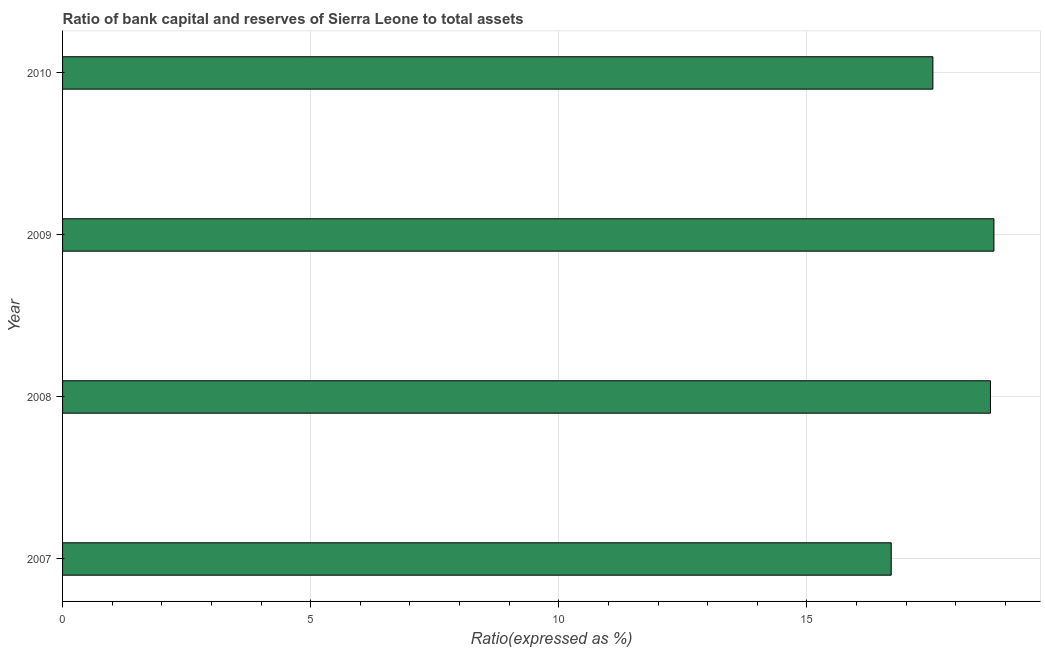Does the graph contain any zero values?
Give a very brief answer. No. Does the graph contain grids?
Make the answer very short. Yes. What is the title of the graph?
Provide a short and direct response. Ratio of bank capital and reserves of Sierra Leone to total assets. What is the label or title of the X-axis?
Your answer should be very brief. Ratio(expressed as %). What is the label or title of the Y-axis?
Offer a very short reply. Year. What is the bank capital to assets ratio in 2010?
Provide a short and direct response. 17.54. Across all years, what is the maximum bank capital to assets ratio?
Provide a succinct answer. 18.77. Across all years, what is the minimum bank capital to assets ratio?
Provide a short and direct response. 16.7. In which year was the bank capital to assets ratio maximum?
Provide a short and direct response. 2009. What is the sum of the bank capital to assets ratio?
Your response must be concise. 71.71. What is the difference between the bank capital to assets ratio in 2009 and 2010?
Keep it short and to the point. 1.23. What is the average bank capital to assets ratio per year?
Keep it short and to the point. 17.93. What is the median bank capital to assets ratio?
Make the answer very short. 18.12. In how many years, is the bank capital to assets ratio greater than 6 %?
Offer a very short reply. 4. Do a majority of the years between 2010 and 2007 (inclusive) have bank capital to assets ratio greater than 3 %?
Provide a short and direct response. Yes. What is the ratio of the bank capital to assets ratio in 2007 to that in 2010?
Your response must be concise. 0.95. What is the difference between the highest and the second highest bank capital to assets ratio?
Your response must be concise. 0.07. Is the sum of the bank capital to assets ratio in 2009 and 2010 greater than the maximum bank capital to assets ratio across all years?
Ensure brevity in your answer.  Yes. What is the difference between the highest and the lowest bank capital to assets ratio?
Ensure brevity in your answer.  2.07. In how many years, is the bank capital to assets ratio greater than the average bank capital to assets ratio taken over all years?
Give a very brief answer. 2. How many bars are there?
Provide a short and direct response. 4. Are all the bars in the graph horizontal?
Make the answer very short. Yes. What is the difference between two consecutive major ticks on the X-axis?
Your answer should be very brief. 5. What is the Ratio(expressed as %) of 2009?
Provide a succinct answer. 18.77. What is the Ratio(expressed as %) in 2010?
Provide a succinct answer. 17.54. What is the difference between the Ratio(expressed as %) in 2007 and 2009?
Your answer should be compact. -2.07. What is the difference between the Ratio(expressed as %) in 2007 and 2010?
Offer a terse response. -0.84. What is the difference between the Ratio(expressed as %) in 2008 and 2009?
Provide a succinct answer. -0.07. What is the difference between the Ratio(expressed as %) in 2008 and 2010?
Offer a very short reply. 1.16. What is the difference between the Ratio(expressed as %) in 2009 and 2010?
Your answer should be compact. 1.23. What is the ratio of the Ratio(expressed as %) in 2007 to that in 2008?
Your response must be concise. 0.89. What is the ratio of the Ratio(expressed as %) in 2007 to that in 2009?
Make the answer very short. 0.89. What is the ratio of the Ratio(expressed as %) in 2008 to that in 2009?
Provide a short and direct response. 1. What is the ratio of the Ratio(expressed as %) in 2008 to that in 2010?
Provide a succinct answer. 1.07. What is the ratio of the Ratio(expressed as %) in 2009 to that in 2010?
Offer a very short reply. 1.07. 